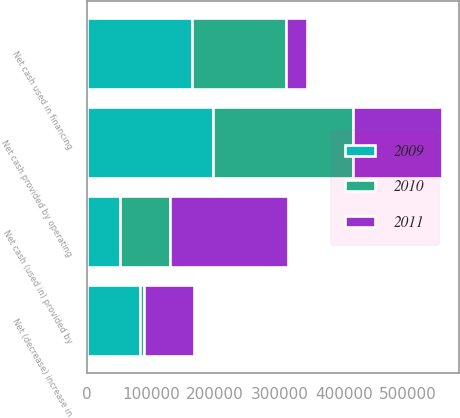<chart> <loc_0><loc_0><loc_500><loc_500><stacked_bar_chart><ecel><fcel>Net cash provided by operating<fcel>Net cash (used in) provided by<fcel>Net cash used in financing<fcel>Net (decrease) increase in<nl><fcel>2010<fcel>217633<fcel>77723<fcel>145569<fcel>5659<nl><fcel>2011<fcel>138459<fcel>184457<fcel>32797<fcel>78795<nl><fcel>2009<fcel>195804<fcel>51545<fcel>164279<fcel>83070<nl></chart> 